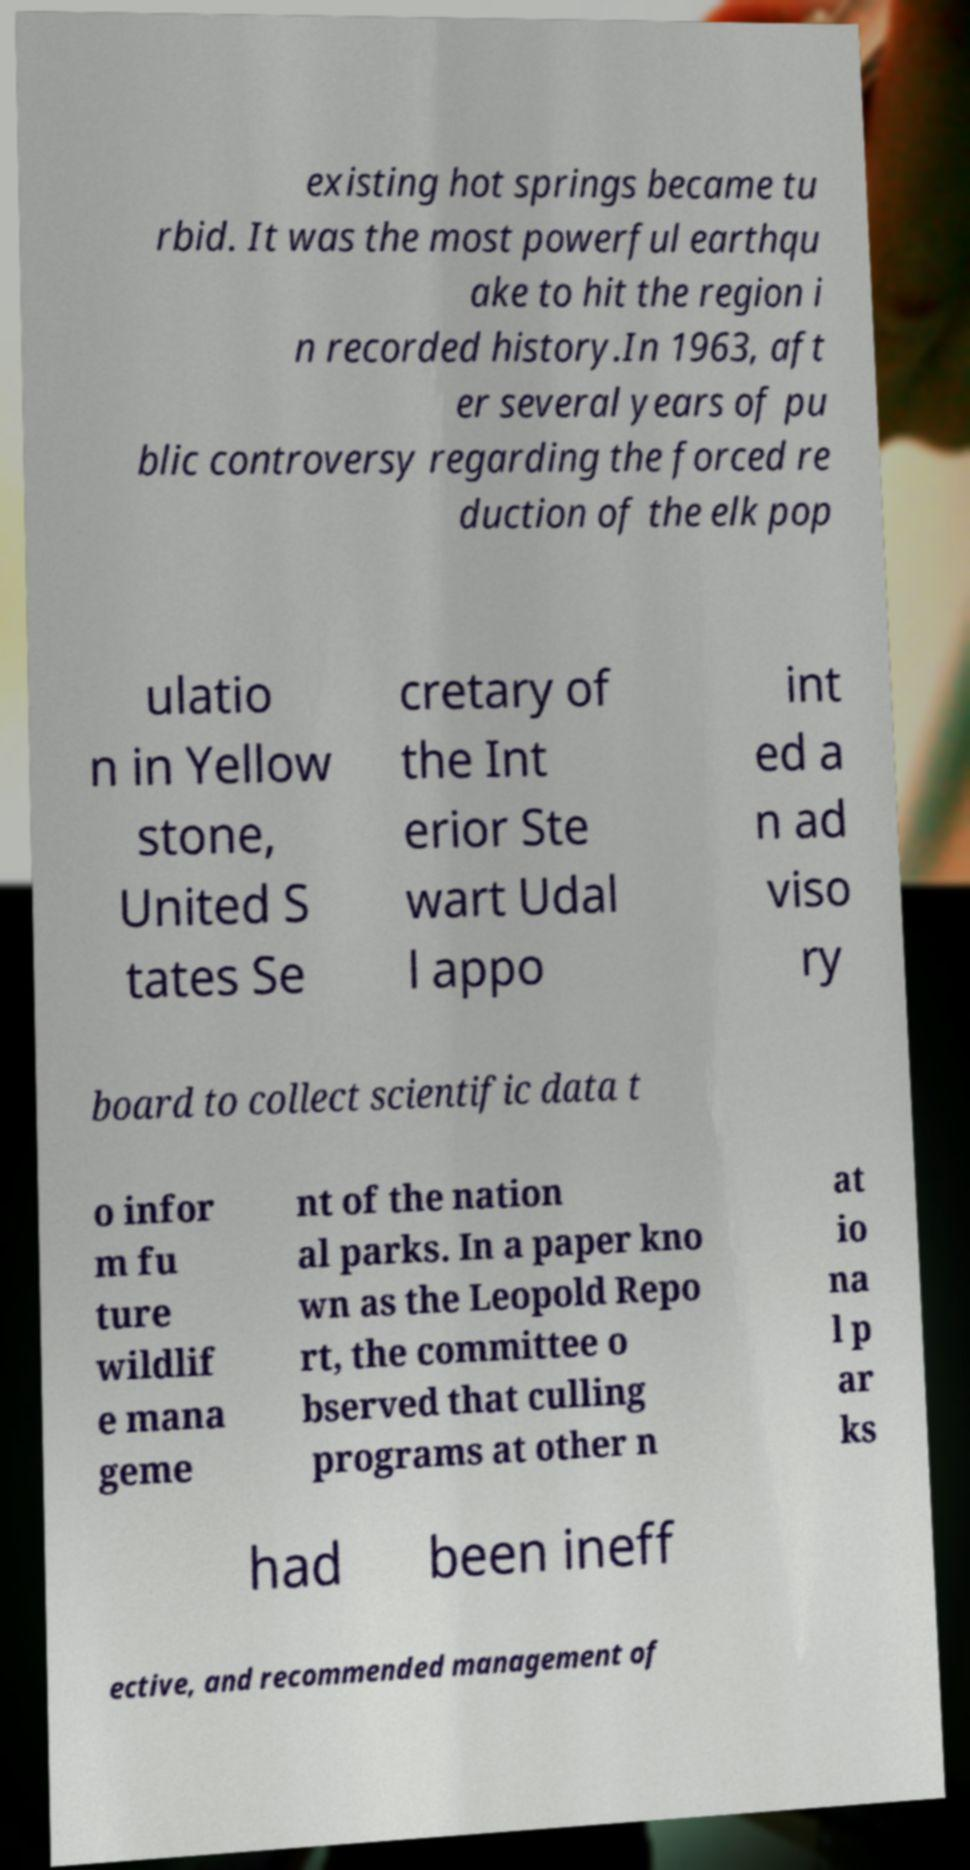Could you extract and type out the text from this image? existing hot springs became tu rbid. It was the most powerful earthqu ake to hit the region i n recorded history.In 1963, aft er several years of pu blic controversy regarding the forced re duction of the elk pop ulatio n in Yellow stone, United S tates Se cretary of the Int erior Ste wart Udal l appo int ed a n ad viso ry board to collect scientific data t o infor m fu ture wildlif e mana geme nt of the nation al parks. In a paper kno wn as the Leopold Repo rt, the committee o bserved that culling programs at other n at io na l p ar ks had been ineff ective, and recommended management of 